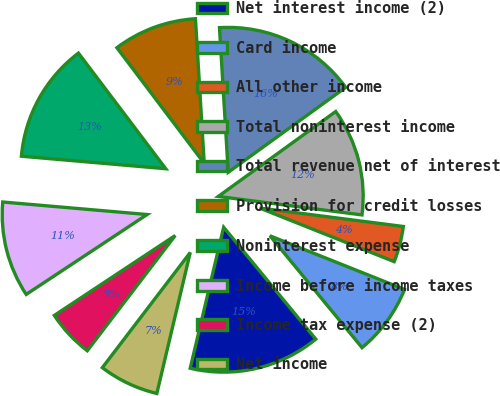Convert chart to OTSL. <chart><loc_0><loc_0><loc_500><loc_500><pie_chart><fcel>Net interest income (2)<fcel>Card income<fcel>All other income<fcel>Total noninterest income<fcel>Total revenue net of interest<fcel>Provision for credit losses<fcel>Noninterest expense<fcel>Income before income taxes<fcel>Income tax expense (2)<fcel>Net income<nl><fcel>14.67%<fcel>8.0%<fcel>4.0%<fcel>12.0%<fcel>16.0%<fcel>9.33%<fcel>13.33%<fcel>10.67%<fcel>5.33%<fcel>6.67%<nl></chart> 